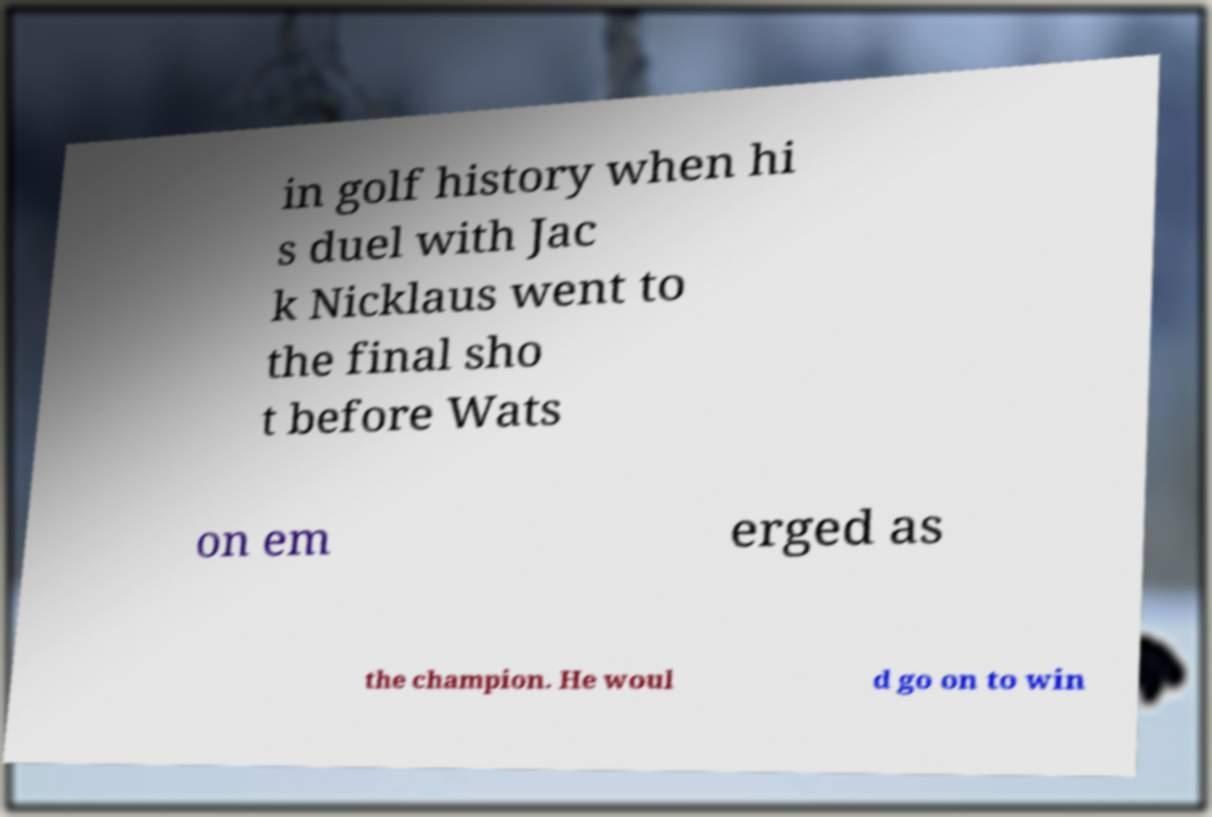I need the written content from this picture converted into text. Can you do that? in golf history when hi s duel with Jac k Nicklaus went to the final sho t before Wats on em erged as the champion. He woul d go on to win 